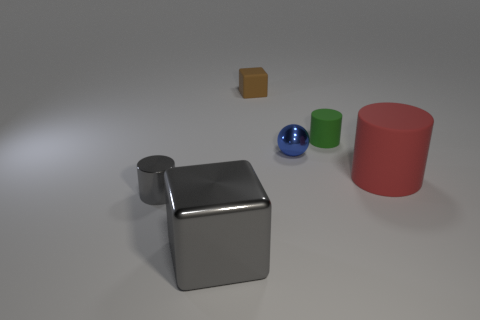There is a tiny shiny object on the left side of the tiny matte cube; is it the same shape as the matte thing that is to the right of the tiny matte cylinder?
Make the answer very short. Yes. There is a large object that is behind the cylinder on the left side of the tiny brown object; what is its shape?
Offer a terse response. Cylinder. There is a metal cylinder that is the same color as the big metallic thing; what size is it?
Make the answer very short. Small. Are there any other small red balls that have the same material as the sphere?
Offer a very short reply. No. What is the material of the block behind the small blue sphere?
Provide a succinct answer. Rubber. What material is the large gray object?
Give a very brief answer. Metal. Are the gray cylinder that is in front of the green matte cylinder and the brown thing made of the same material?
Keep it short and to the point. No. Is the number of tiny gray objects to the right of the tiny blue shiny ball less than the number of big gray metallic cylinders?
Your answer should be very brief. No. What color is the metal object that is the same size as the blue metallic sphere?
Offer a terse response. Gray. How many big gray objects are the same shape as the brown thing?
Give a very brief answer. 1. 